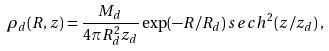<formula> <loc_0><loc_0><loc_500><loc_500>\rho _ { d } ( R , z ) = \frac { M _ { d } } { 4 \pi R ^ { 2 } _ { d } z _ { d } } \exp ( - R / R _ { d } ) \, s e c h ^ { 2 } ( z / z _ { d } ) \, ,</formula> 